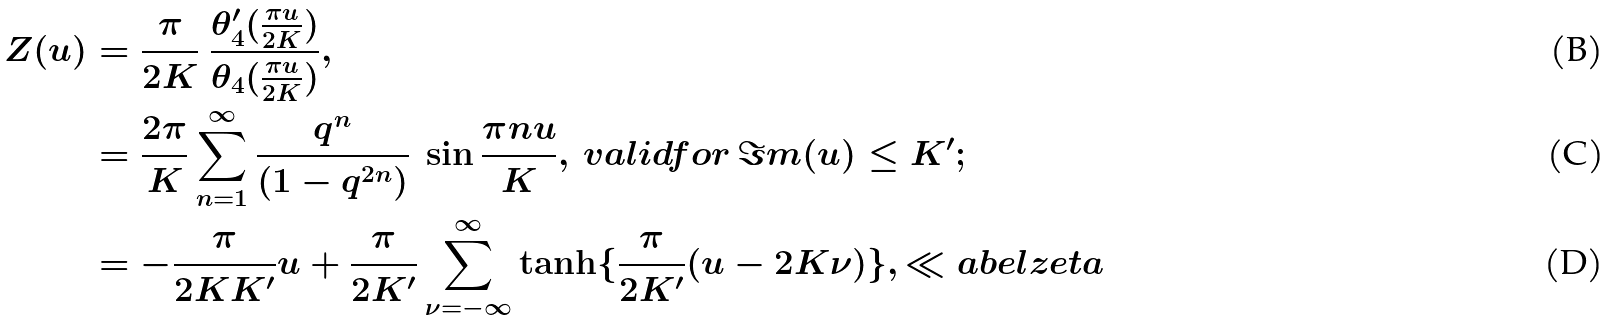Convert formula to latex. <formula><loc_0><loc_0><loc_500><loc_500>Z ( u ) & = \frac { \pi } { 2 K } \ \frac { \theta ^ { \prime } _ { 4 } ( \frac { \pi u } { 2 K } ) } { \theta _ { 4 } ( \frac { \pi u } { 2 K } ) } , \\ & = \frac { 2 \pi } { K } \sum _ { n = 1 } ^ { \infty } \frac { q ^ { n } } { ( 1 - q ^ { 2 n } ) } \ \sin \frac { \pi n u } { K } , \, v a l i d f o r \, \Im m ( u ) \leq K ^ { \prime } ; \\ & = - \frac { \pi } { 2 K K ^ { \prime } } u + \frac { \pi } { 2 K ^ { \prime } } \sum _ { \nu = - \infty } ^ { \infty } \tanh \{ \frac { \pi } { 2 K ^ { \prime } } ( u - 2 K \nu ) \} , \ll a b e l { z e t a }</formula> 